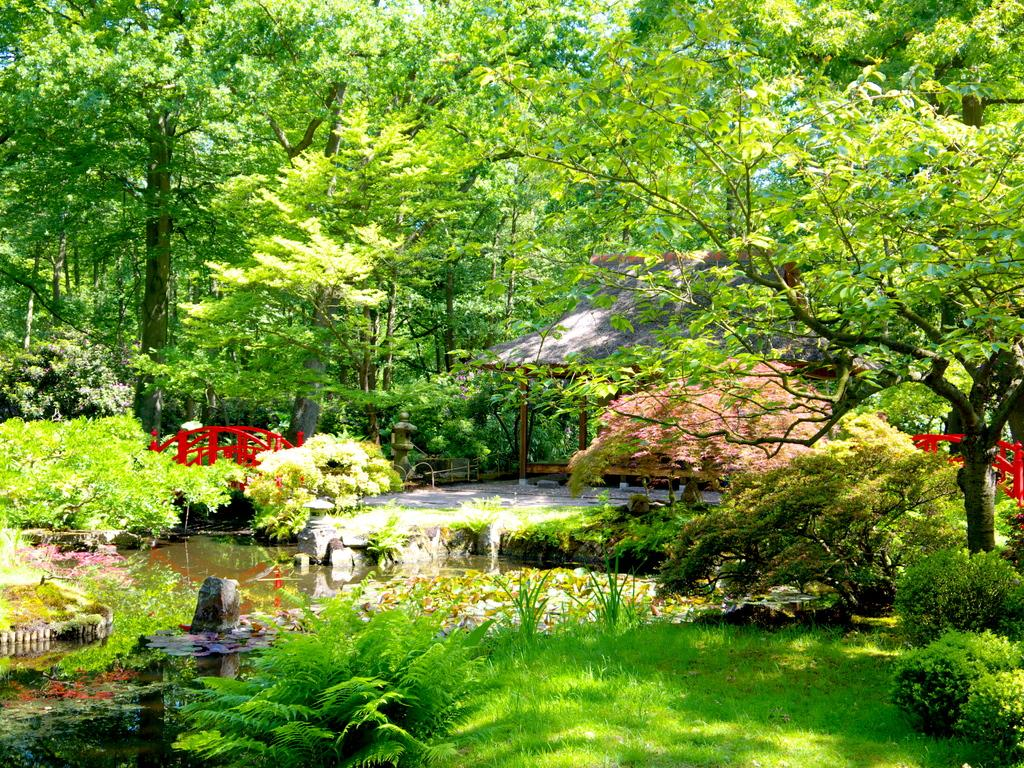What can be found on the left side of the image? There is a small pond on the left side of the image. What is located near the pond? There are plants and trees near the pond. What type of terrain is the pond situated on? The pond is located on a grassland. What can be seen in the background of the image? There is a bridge in the background of the image. What is the name of the system used to create the pond in the image? There is no information about a system used to create the pond in the image, and therefore no name can be provided. 